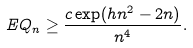<formula> <loc_0><loc_0><loc_500><loc_500>E Q _ { n } \geq \frac { c \exp ( h n ^ { 2 } - 2 n ) } { n ^ { 4 } } .</formula> 